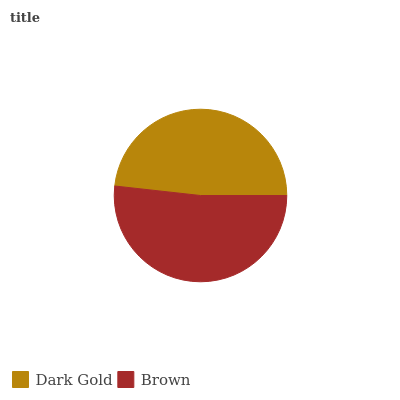Is Dark Gold the minimum?
Answer yes or no. Yes. Is Brown the maximum?
Answer yes or no. Yes. Is Brown the minimum?
Answer yes or no. No. Is Brown greater than Dark Gold?
Answer yes or no. Yes. Is Dark Gold less than Brown?
Answer yes or no. Yes. Is Dark Gold greater than Brown?
Answer yes or no. No. Is Brown less than Dark Gold?
Answer yes or no. No. Is Brown the high median?
Answer yes or no. Yes. Is Dark Gold the low median?
Answer yes or no. Yes. Is Dark Gold the high median?
Answer yes or no. No. Is Brown the low median?
Answer yes or no. No. 